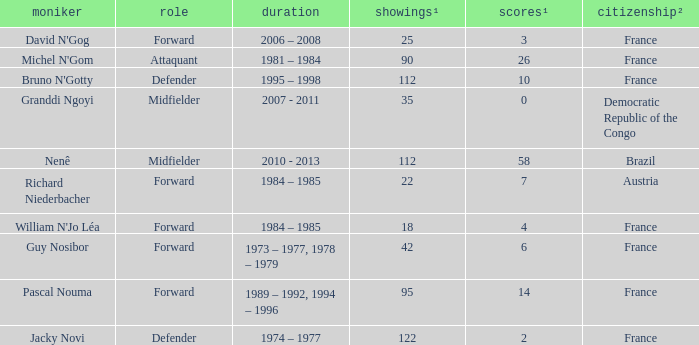List the player that scored 4 times. William N'Jo Léa. 